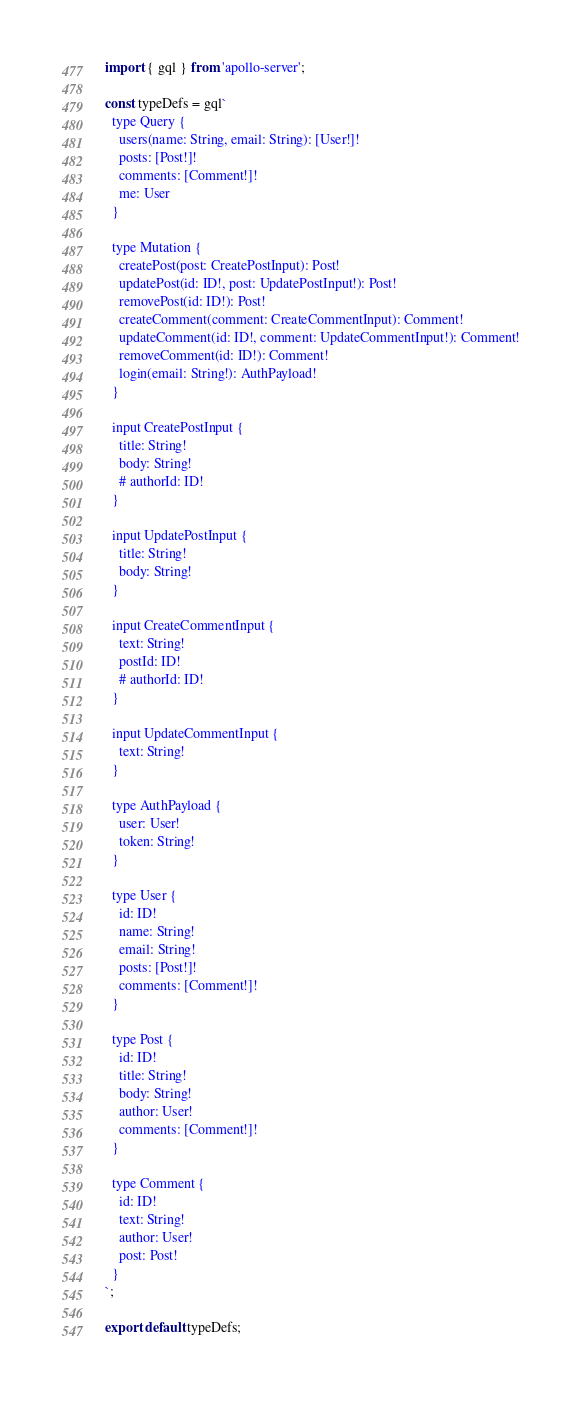<code> <loc_0><loc_0><loc_500><loc_500><_JavaScript_>import { gql } from 'apollo-server';

const typeDefs = gql`
  type Query {
    users(name: String, email: String): [User!]!
    posts: [Post!]!
    comments: [Comment!]!
    me: User
  }

  type Mutation {
    createPost(post: CreatePostInput): Post!
    updatePost(id: ID!, post: UpdatePostInput!): Post!
    removePost(id: ID!): Post!
    createComment(comment: CreateCommentInput): Comment!
    updateComment(id: ID!, comment: UpdateCommentInput!): Comment!
    removeComment(id: ID!): Comment!
    login(email: String!): AuthPayload!
  }

  input CreatePostInput {
    title: String!
    body: String!
    # authorId: ID!
  }

  input UpdatePostInput {
    title: String!
    body: String!
  }

  input CreateCommentInput {
    text: String!
    postId: ID!
    # authorId: ID!
  }

  input UpdateCommentInput {
    text: String!
  }

  type AuthPayload {
    user: User!
    token: String!
  }

  type User {
    id: ID!
    name: String!
    email: String!
    posts: [Post!]!
    comments: [Comment!]!
  }

  type Post {
    id: ID!
    title: String!
    body: String!
    author: User!
    comments: [Comment!]!
  }

  type Comment {
    id: ID!
    text: String!
    author: User!
    post: Post!
  }
`;

export default typeDefs;
</code> 